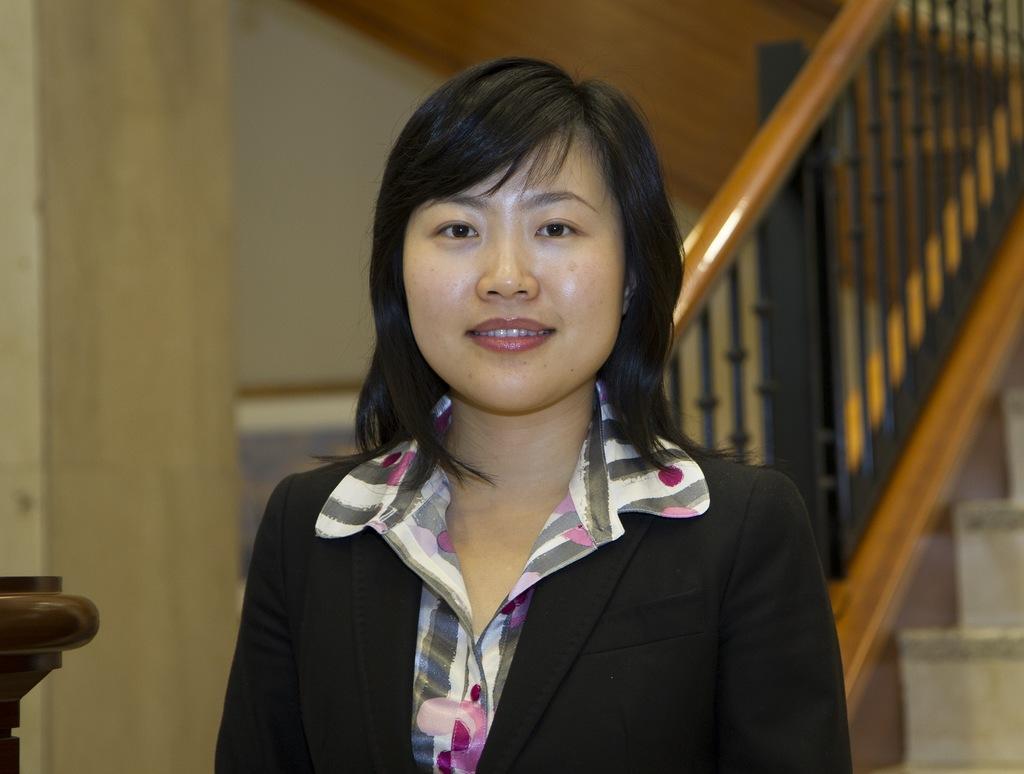Can you describe this image briefly? In this picture I can see a woman in the middle, she is wearing a coat. On the right side I can see the staircase. 